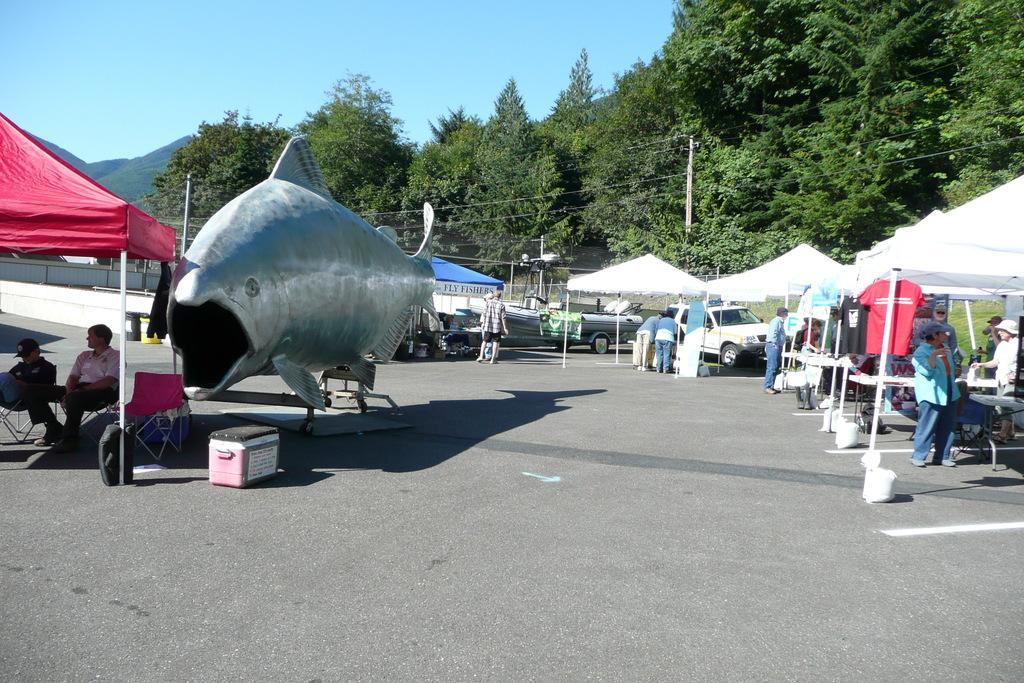Please provide a concise description of this image. This image is clicked on the roads. There are many people in this image. In the front, there are tents. In the middle, there is an artificial fish. In the background, there are trees and mountains. At the top, there is a sky. 